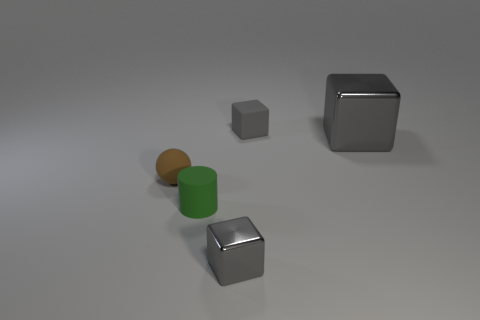Are there any rubber things that have the same size as the matte cylinder?
Offer a terse response. Yes. The green thing has what size?
Provide a succinct answer. Small. How many cylinders have the same size as the rubber cube?
Offer a terse response. 1. Are there fewer green cylinders left of the brown matte sphere than small matte blocks that are on the left side of the green rubber thing?
Offer a terse response. No. How big is the cube to the right of the gray rubber thing behind the thing in front of the tiny green object?
Your answer should be compact. Large. How big is the gray block that is left of the big shiny block and behind the tiny brown rubber object?
Make the answer very short. Small. There is a small brown thing that is behind the object that is in front of the tiny green thing; what is its shape?
Provide a succinct answer. Sphere. Is there anything else that is the same color as the ball?
Provide a short and direct response. No. What shape is the metallic thing behind the rubber cylinder?
Provide a short and direct response. Cube. What is the shape of the tiny object that is both behind the tiny shiny thing and in front of the tiny sphere?
Your response must be concise. Cylinder. 